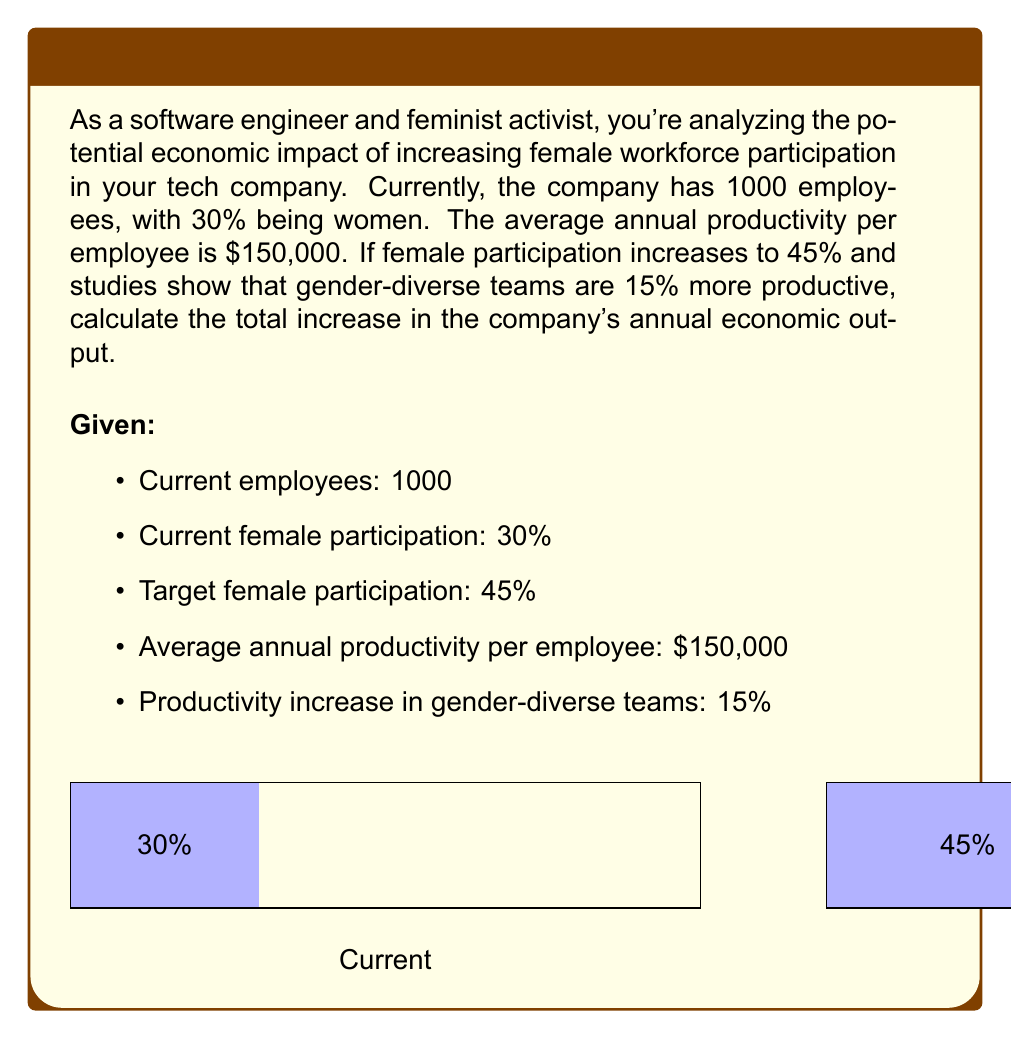Provide a solution to this math problem. Let's break this down step-by-step:

1) First, let's calculate the current economic output:
   $$\text{Current Output} = 1000 \times \$150,000 = \$150,000,000$$

2) Now, let's calculate the new number of employees for each gender:
   Women: $1000 \times 45\% = 450$
   Men: $1000 \times 55\% = 550$

3) The productivity increase applies to the entire workforce due to increased diversity. So, the new productivity per employee is:
   $$\text{New Productivity} = \$150,000 \times 1.15 = \$172,500$$

4) Calculate the new economic output:
   $$\text{New Output} = 1000 \times \$172,500 = \$172,500,000$$

5) Finally, calculate the increase in economic output:
   $$\text{Increase} = \$172,500,000 - \$150,000,000 = \$22,500,000$$
Answer: $22,500,000 